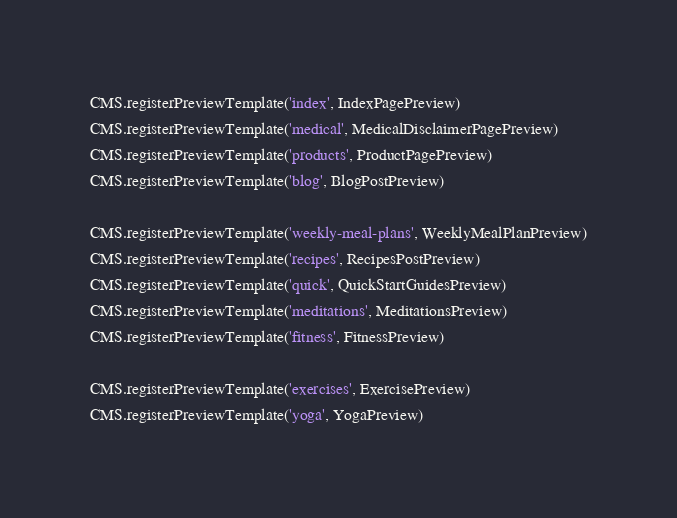<code> <loc_0><loc_0><loc_500><loc_500><_JavaScript_>
CMS.registerPreviewTemplate('index', IndexPagePreview)
CMS.registerPreviewTemplate('medical', MedicalDisclaimerPagePreview)
CMS.registerPreviewTemplate('products', ProductPagePreview)
CMS.registerPreviewTemplate('blog', BlogPostPreview)

CMS.registerPreviewTemplate('weekly-meal-plans', WeeklyMealPlanPreview)
CMS.registerPreviewTemplate('recipes', RecipesPostPreview)
CMS.registerPreviewTemplate('quick', QuickStartGuidesPreview)
CMS.registerPreviewTemplate('meditations', MeditationsPreview)
CMS.registerPreviewTemplate('fitness', FitnessPreview)

CMS.registerPreviewTemplate('exercises', ExercisePreview)
CMS.registerPreviewTemplate('yoga', YogaPreview)
</code> 